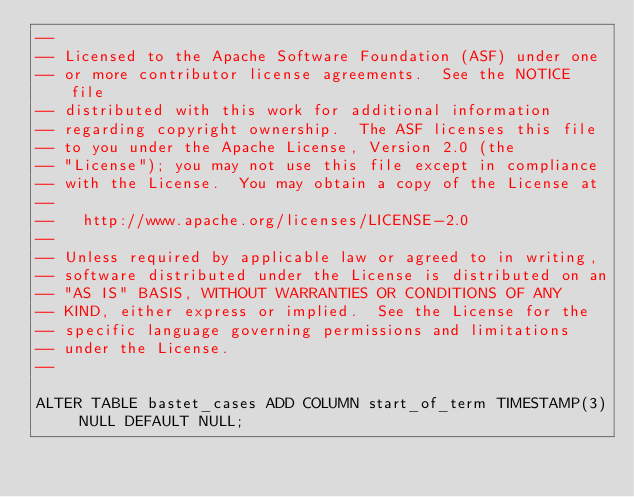Convert code to text. <code><loc_0><loc_0><loc_500><loc_500><_SQL_>--
-- Licensed to the Apache Software Foundation (ASF) under one
-- or more contributor license agreements.  See the NOTICE file
-- distributed with this work for additional information
-- regarding copyright ownership.  The ASF licenses this file
-- to you under the Apache License, Version 2.0 (the
-- "License"); you may not use this file except in compliance
-- with the License.  You may obtain a copy of the License at
--
--   http://www.apache.org/licenses/LICENSE-2.0
--
-- Unless required by applicable law or agreed to in writing,
-- software distributed under the License is distributed on an
-- "AS IS" BASIS, WITHOUT WARRANTIES OR CONDITIONS OF ANY
-- KIND, either express or implied.  See the License for the
-- specific language governing permissions and limitations
-- under the License.
--

ALTER TABLE bastet_cases ADD COLUMN start_of_term TIMESTAMP(3) NULL DEFAULT NULL;</code> 